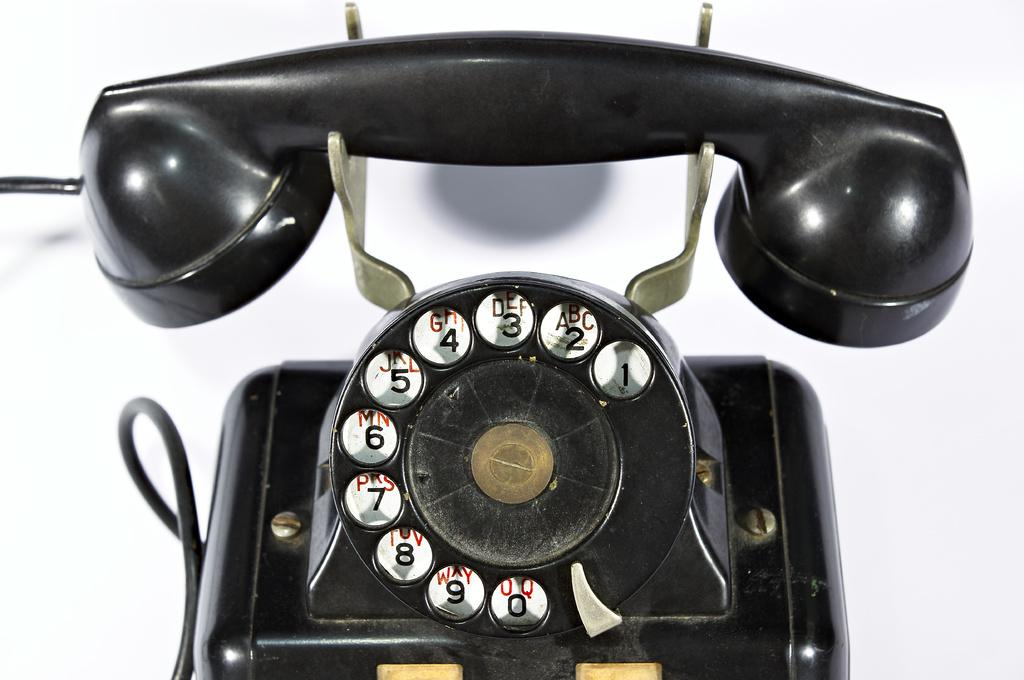What object can be seen in the image? There is a telephone in the image. What is the color of the telephone? The telephone is black in color. What is the surface beneath the telephone? The telephone is on a white surface. What type of dirt can be seen on the telephone in the image? There is no dirt visible on the telephone in the image. Can you see any beetles crawling on the telephone in the image? There are no beetles present in the image. 